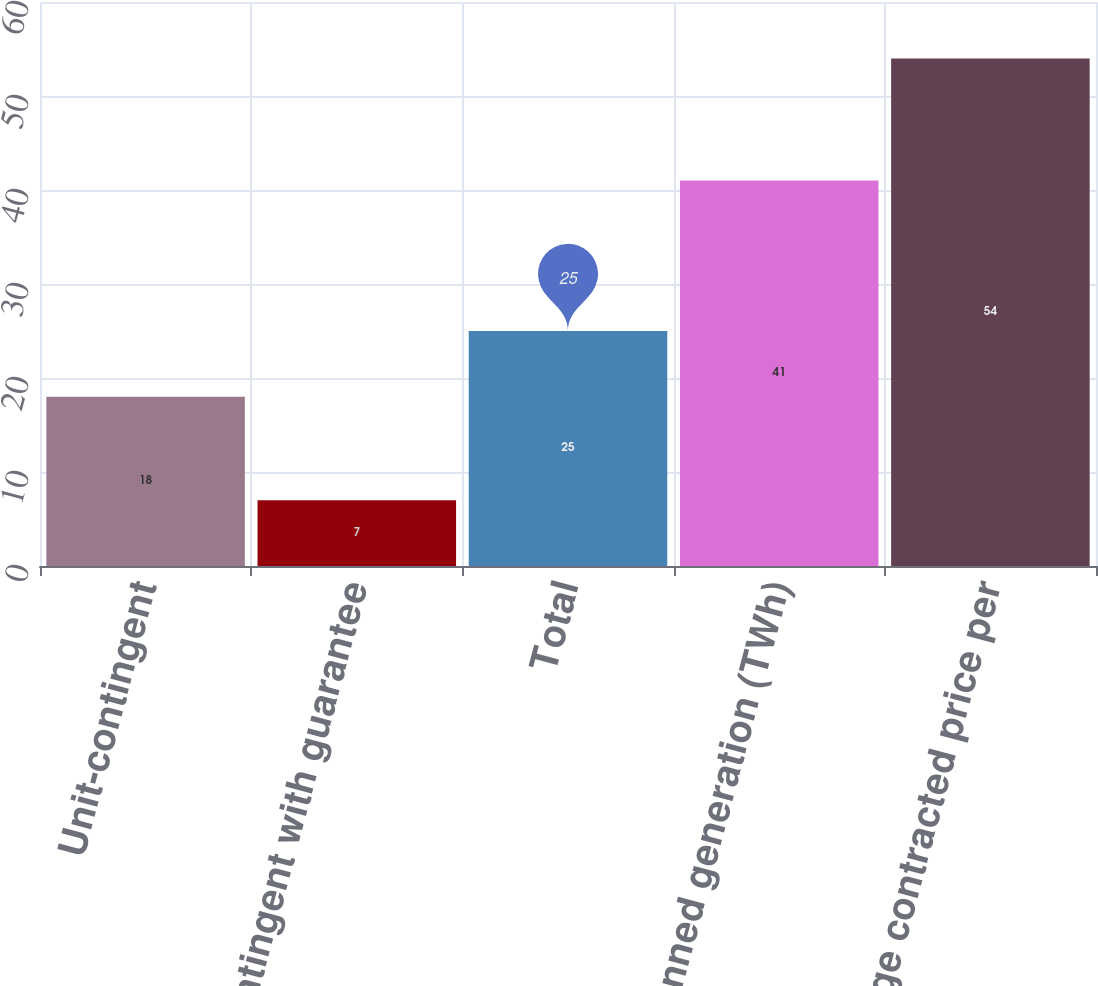Convert chart to OTSL. <chart><loc_0><loc_0><loc_500><loc_500><bar_chart><fcel>Unit-contingent<fcel>Unit-contingent with guarantee<fcel>Total<fcel>Planned generation (TWh)<fcel>Average contracted price per<nl><fcel>18<fcel>7<fcel>25<fcel>41<fcel>54<nl></chart> 